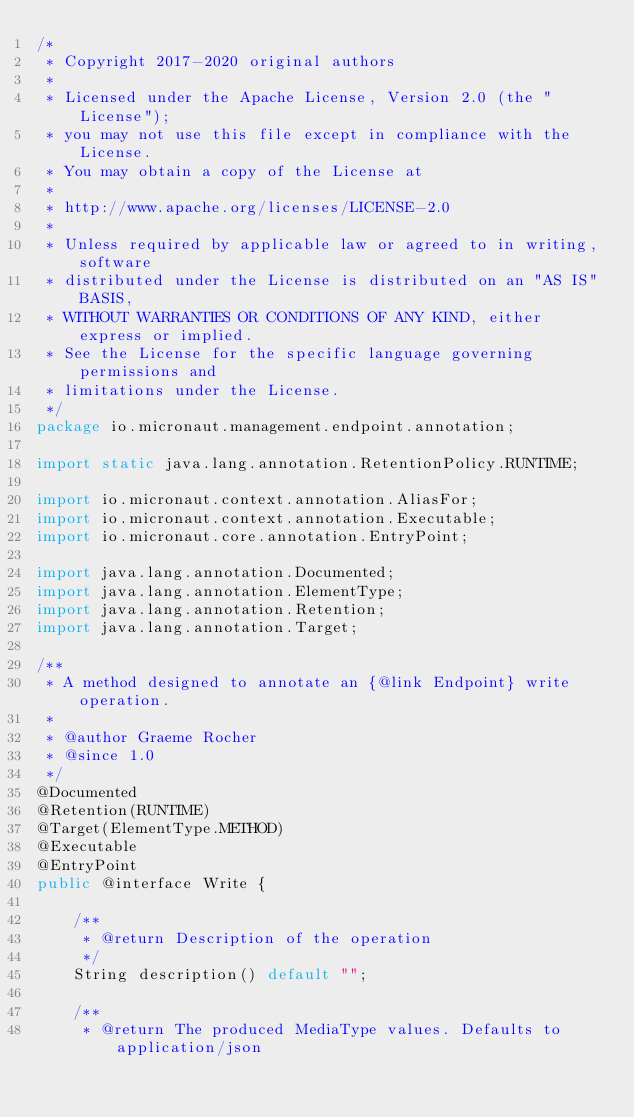<code> <loc_0><loc_0><loc_500><loc_500><_Java_>/*
 * Copyright 2017-2020 original authors
 *
 * Licensed under the Apache License, Version 2.0 (the "License");
 * you may not use this file except in compliance with the License.
 * You may obtain a copy of the License at
 *
 * http://www.apache.org/licenses/LICENSE-2.0
 *
 * Unless required by applicable law or agreed to in writing, software
 * distributed under the License is distributed on an "AS IS" BASIS,
 * WITHOUT WARRANTIES OR CONDITIONS OF ANY KIND, either express or implied.
 * See the License for the specific language governing permissions and
 * limitations under the License.
 */
package io.micronaut.management.endpoint.annotation;

import static java.lang.annotation.RetentionPolicy.RUNTIME;

import io.micronaut.context.annotation.AliasFor;
import io.micronaut.context.annotation.Executable;
import io.micronaut.core.annotation.EntryPoint;

import java.lang.annotation.Documented;
import java.lang.annotation.ElementType;
import java.lang.annotation.Retention;
import java.lang.annotation.Target;

/**
 * A method designed to annotate an {@link Endpoint} write operation.
 *
 * @author Graeme Rocher
 * @since 1.0
 */
@Documented
@Retention(RUNTIME)
@Target(ElementType.METHOD)
@Executable
@EntryPoint
public @interface Write {

    /**
     * @return Description of the operation
     */
    String description() default "";

    /**
     * @return The produced MediaType values. Defaults to application/json</code> 